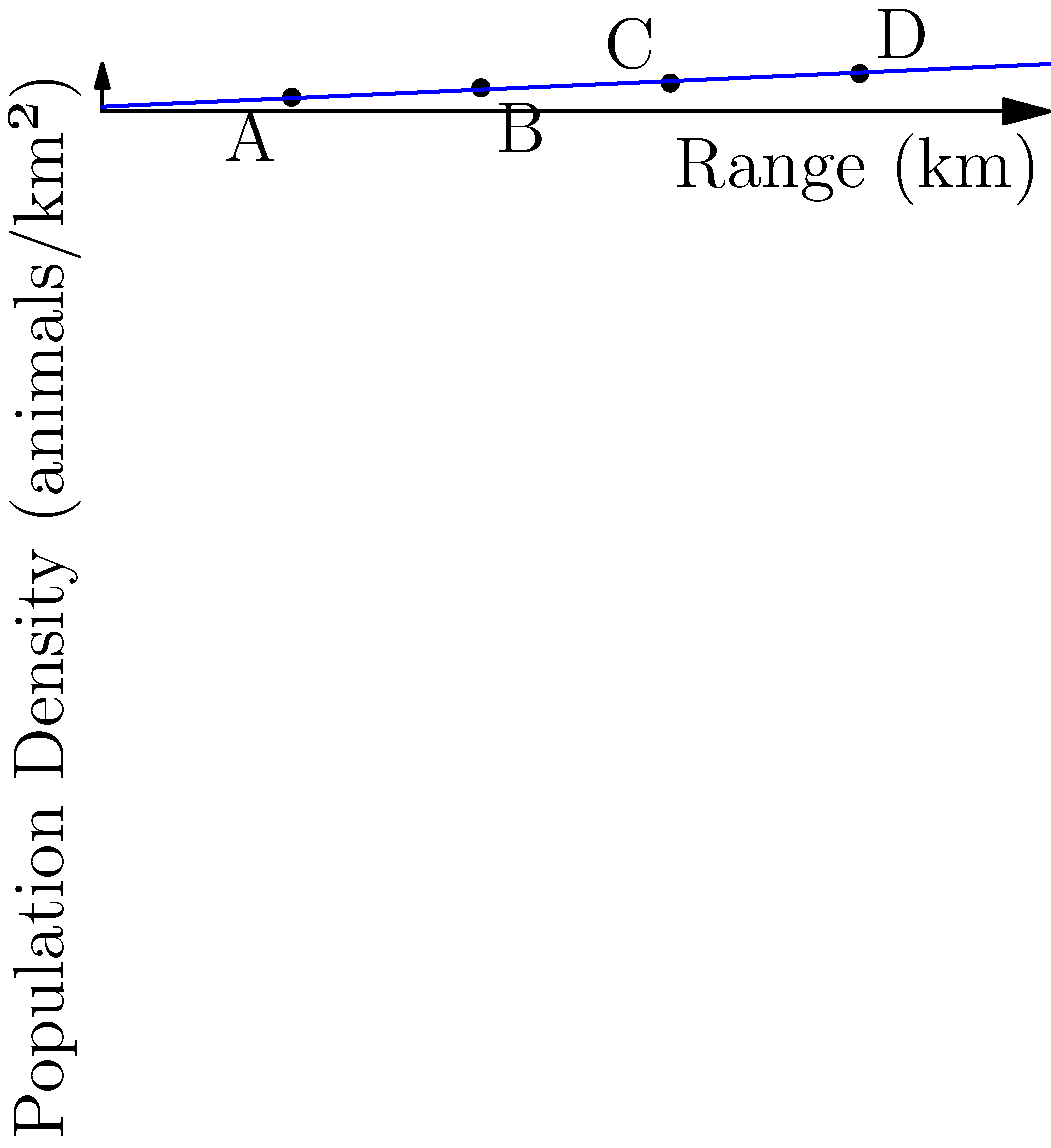As a wildlife conservationist, you're tasked with determining the protected habitat area needed for an endangered species. The graph shows the relationship between the species' range and population density. If the total population is 300 individuals, what is the minimum area of protected habitat required to sustain the species, assuming the highest observed population density? To solve this problem, we'll follow these steps:

1. Identify the highest population density from the graph:
   Point D shows the highest density at 4.0 animals/km².

2. Calculate the required area using the formula:
   $$ \text{Area} = \frac{\text{Total Population}}{\text{Highest Population Density}} $$

3. Plug in the values:
   $$ \text{Area} = \frac{300 \text{ animals}}{4.0 \text{ animals/km²}} $$

4. Perform the calculation:
   $$ \text{Area} = 75 \text{ km²} $$

5. Round up to ensure sufficient space:
   The minimum protected habitat area should be 75 km².

This approach ensures the species has enough space at the highest observed density, prioritizing animal welfare while minimizing the land area needed for protection.
Answer: 75 km² 